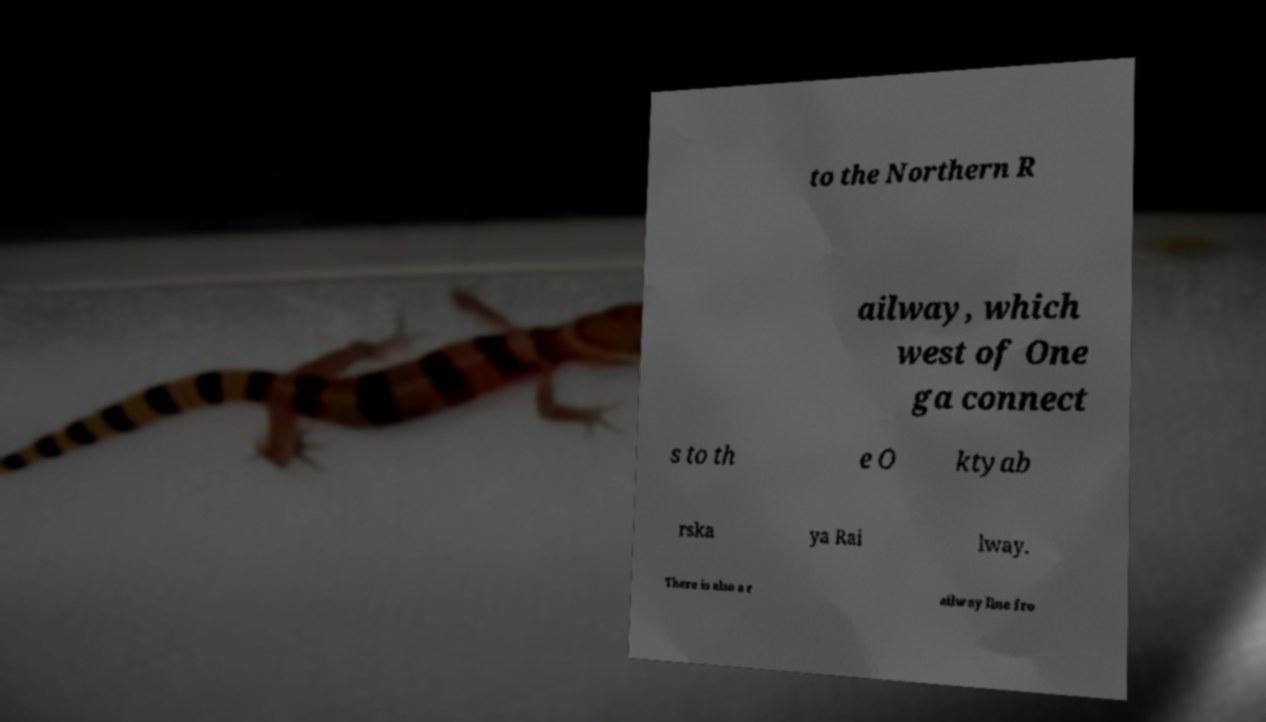Please read and relay the text visible in this image. What does it say? to the Northern R ailway, which west of One ga connect s to th e O ktyab rska ya Rai lway. There is also a r ailway line fro 